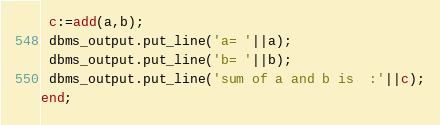Convert code to text. <code><loc_0><loc_0><loc_500><loc_500><_SQL_> c:=add(a,b);
 dbms_output.put_line('a= '||a);
 dbms_output.put_line('b= '||b);
 dbms_output.put_line('sum of a and b is  :'||c);
end;
</code> 